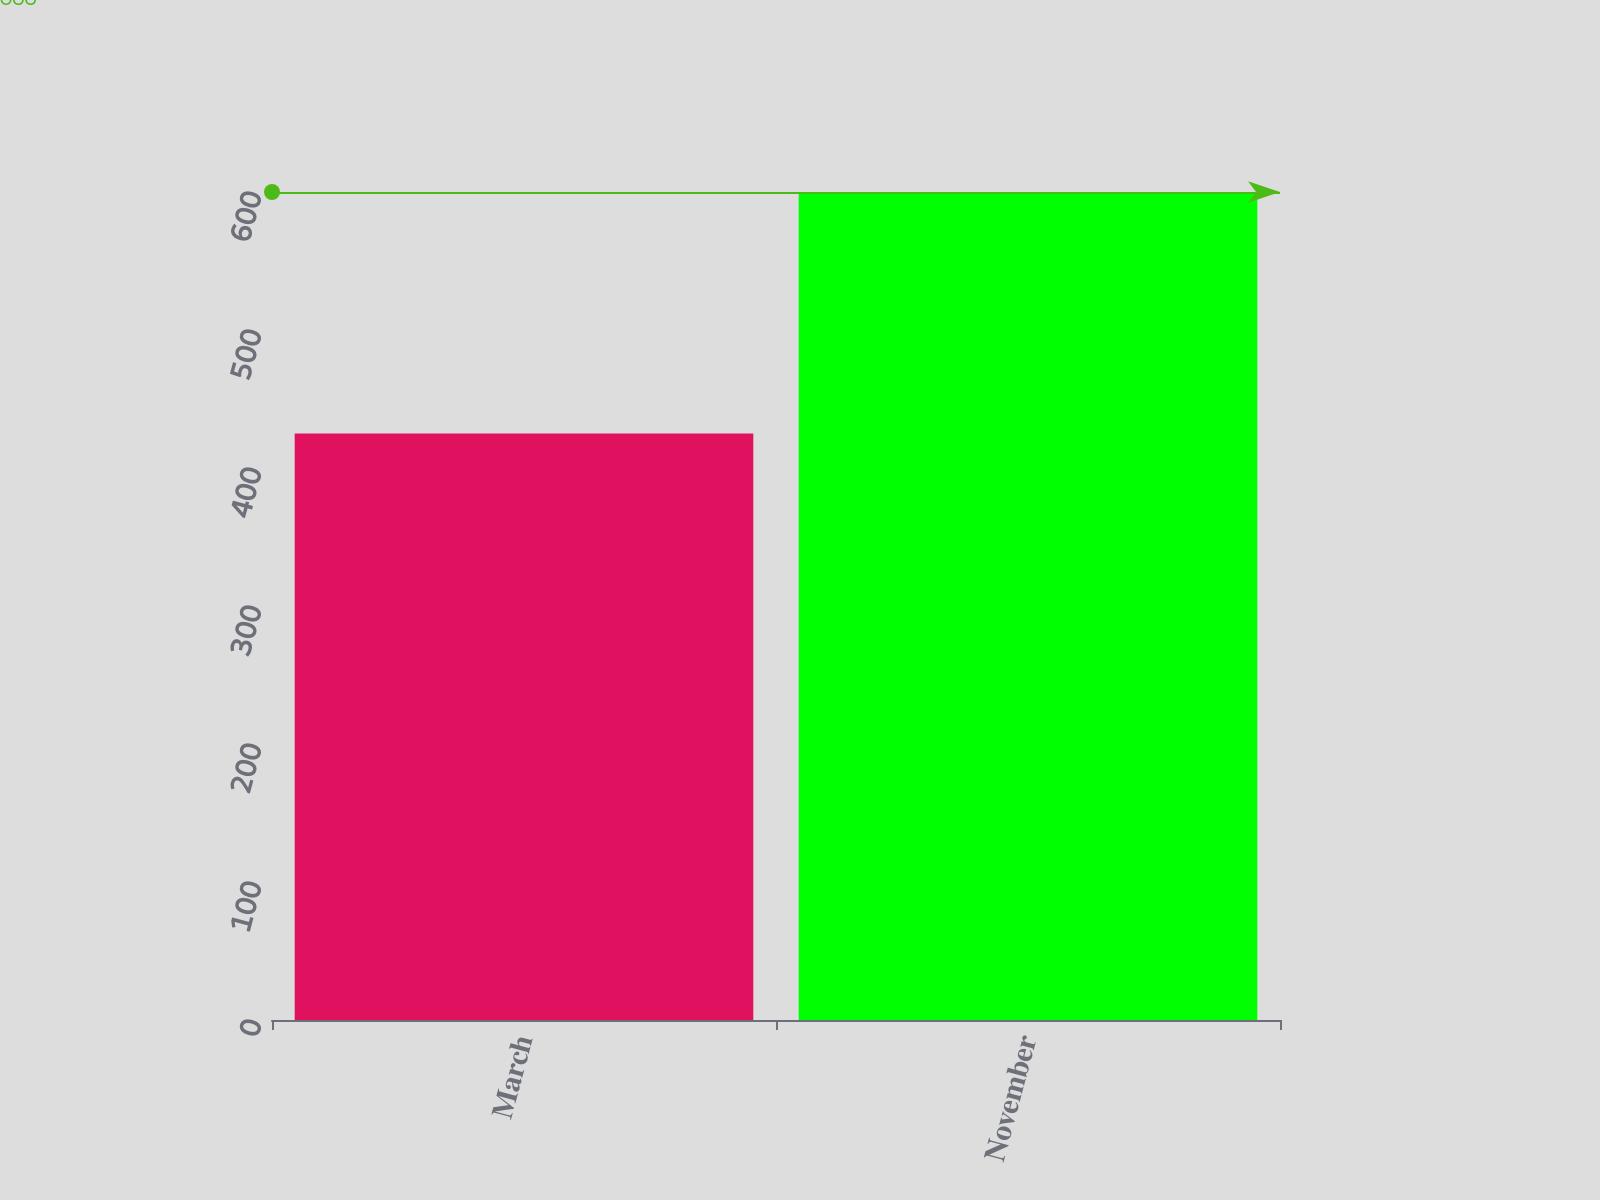Convert chart to OTSL. <chart><loc_0><loc_0><loc_500><loc_500><bar_chart><fcel>March<fcel>November<nl><fcel>425<fcel>600<nl></chart> 